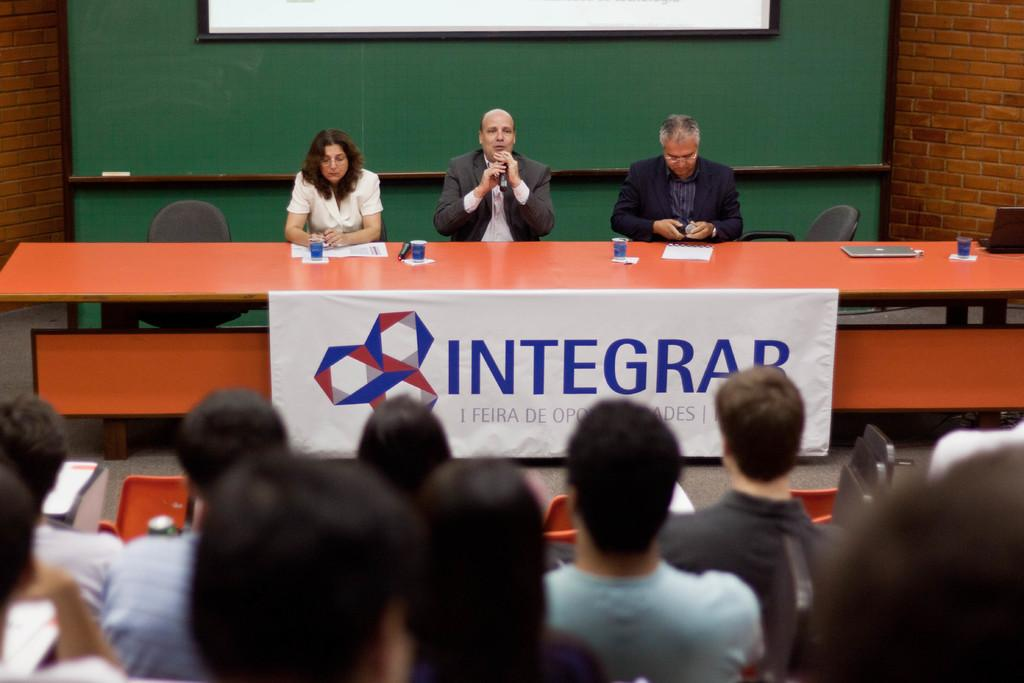How many people are visible in the image? There are many people in the image. Can you describe the seating arrangement of the people in the front? Three people are sitting in the front. What is one person doing in the image? One person is talking into a microphone. What type of fowl can be seen reacting to the person talking into the microphone? There are no fowl present in the image, and therefore no reaction can be observed. 